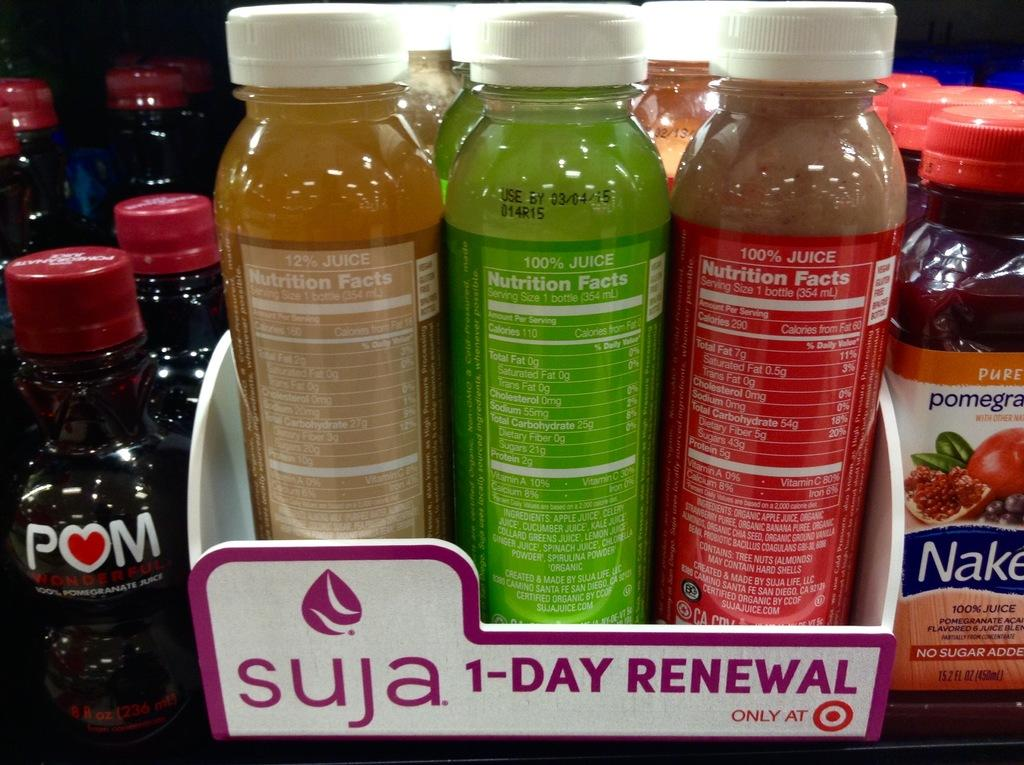<image>
Present a compact description of the photo's key features. The bottle sitting in the middle must be used by 03/04/15 